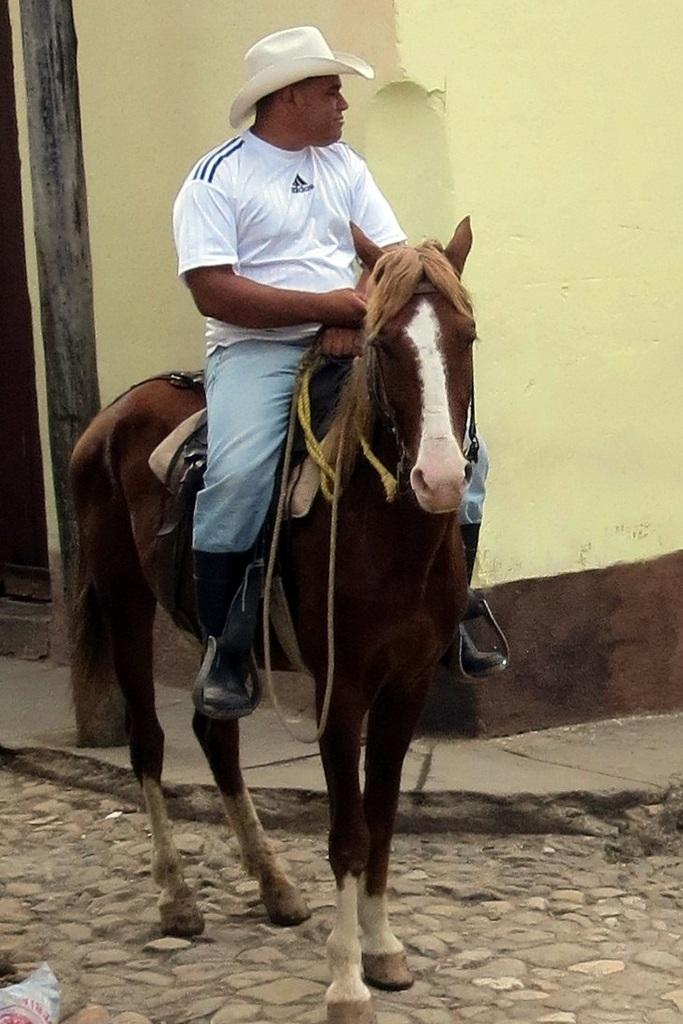What is the main subject of the image? There is a man in the image. What is the man doing in the image? The man is sitting on a horse. What can be seen in the background of the image? There is a wall in the image. What is the color of the wall? The wall is cream-colored. What type of floor is visible in the image? The floor is made of cobblestones. What type of powder is being used to control the wilderness in the image? There is no wilderness or powder present in the image. 